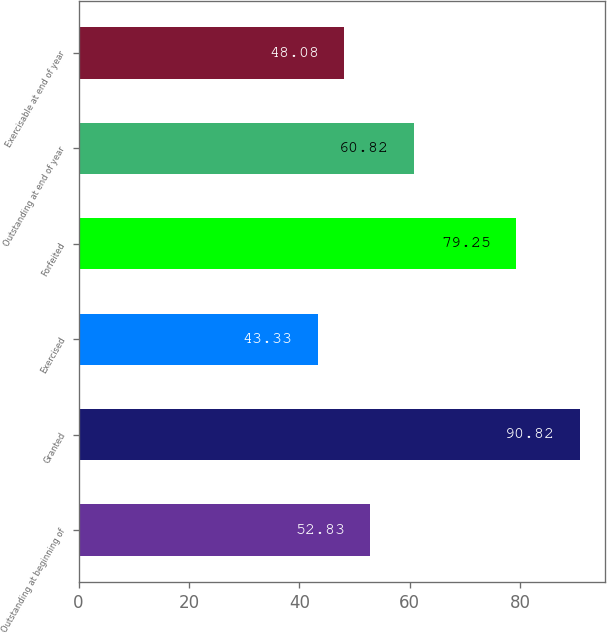Convert chart to OTSL. <chart><loc_0><loc_0><loc_500><loc_500><bar_chart><fcel>Outstanding at beginning of<fcel>Granted<fcel>Exercised<fcel>Forfeited<fcel>Outstanding at end of year<fcel>Exercisable at end of year<nl><fcel>52.83<fcel>90.82<fcel>43.33<fcel>79.25<fcel>60.82<fcel>48.08<nl></chart> 